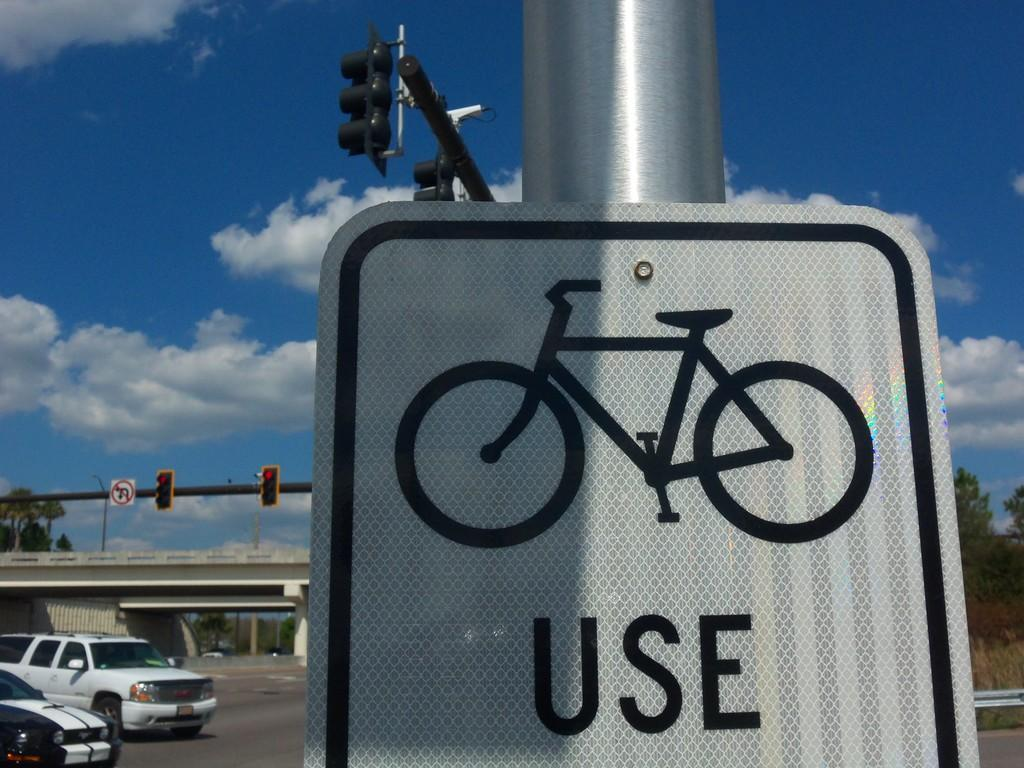<image>
Present a compact description of the photo's key features. A sign with a drawing of a bicycle, and the word "Use" underneath it. 